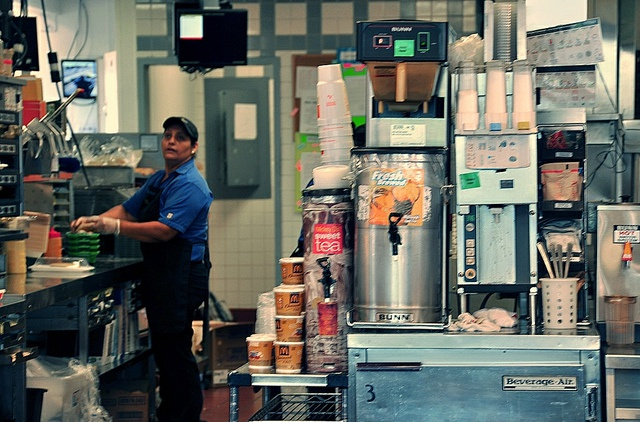Describe the objects in this image and their specific colors. I can see refrigerator in black, teal, darkgray, and blue tones, people in black, navy, maroon, and blue tones, tv in black, beige, and gray tones, dining table in black, beige, darkgray, and gray tones, and cup in black and tan tones in this image. 